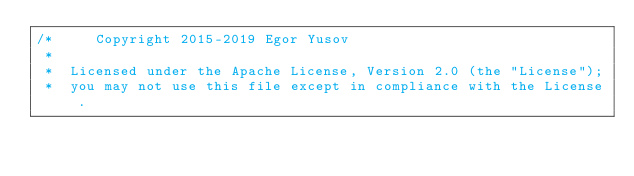Convert code to text. <code><loc_0><loc_0><loc_500><loc_500><_ObjectiveC_>/*     Copyright 2015-2019 Egor Yusov
 *  
 *  Licensed under the Apache License, Version 2.0 (the "License");
 *  you may not use this file except in compliance with the License.</code> 